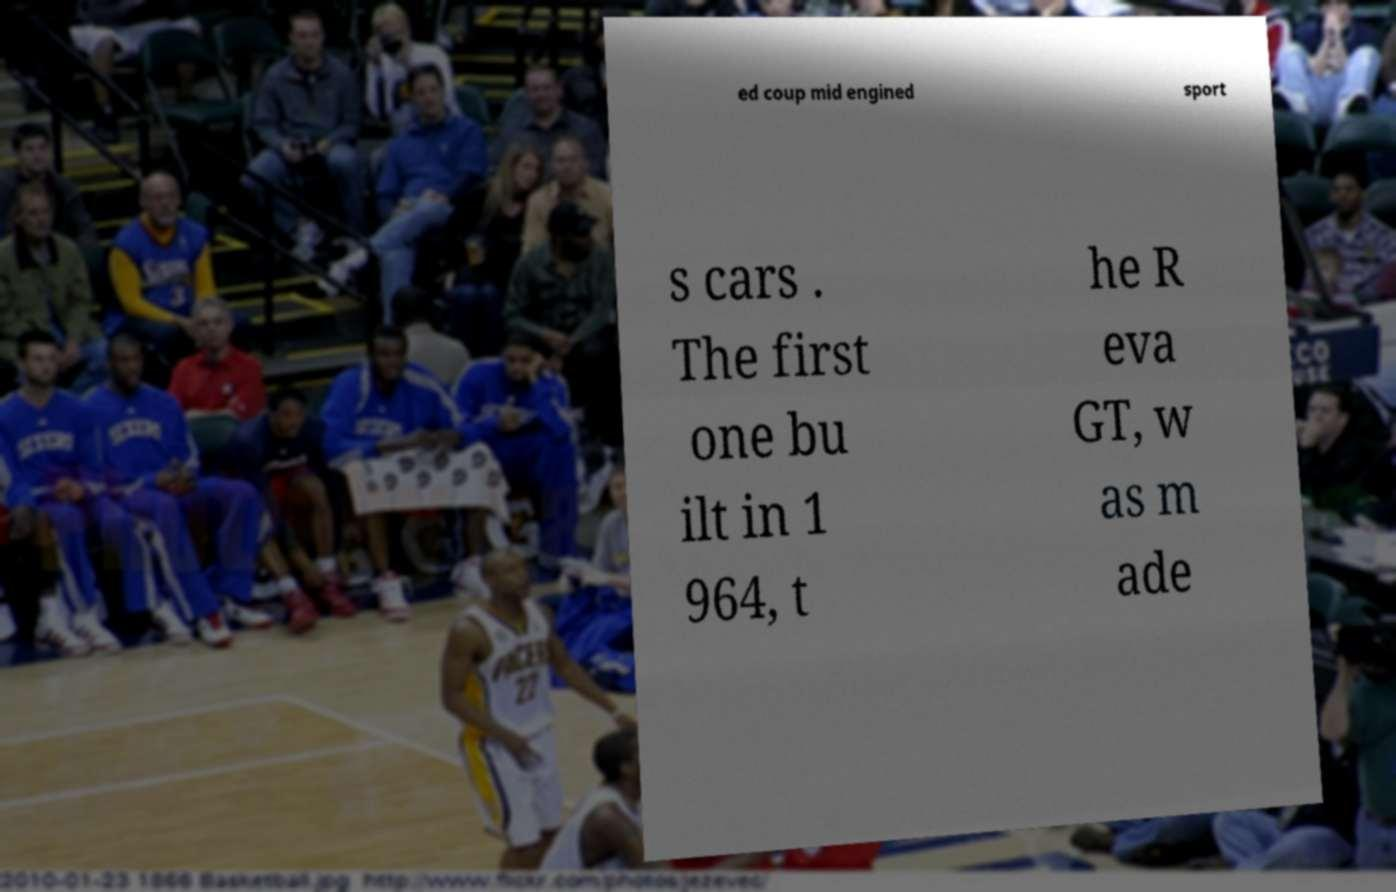Can you accurately transcribe the text from the provided image for me? ed coup mid engined sport s cars . The first one bu ilt in 1 964, t he R eva GT, w as m ade 